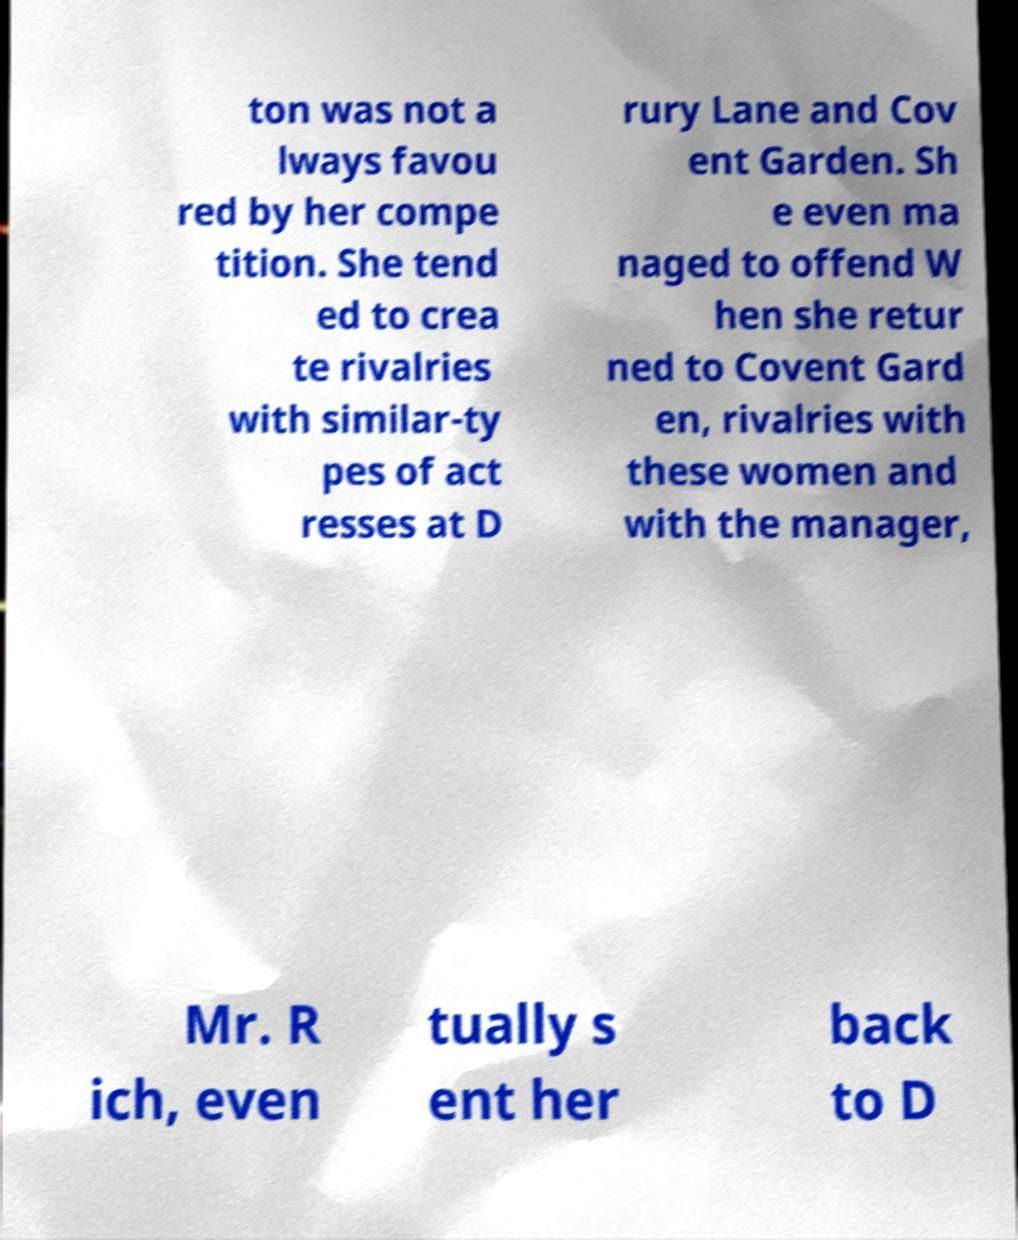There's text embedded in this image that I need extracted. Can you transcribe it verbatim? ton was not a lways favou red by her compe tition. She tend ed to crea te rivalries with similar-ty pes of act resses at D rury Lane and Cov ent Garden. Sh e even ma naged to offend W hen she retur ned to Covent Gard en, rivalries with these women and with the manager, Mr. R ich, even tually s ent her back to D 